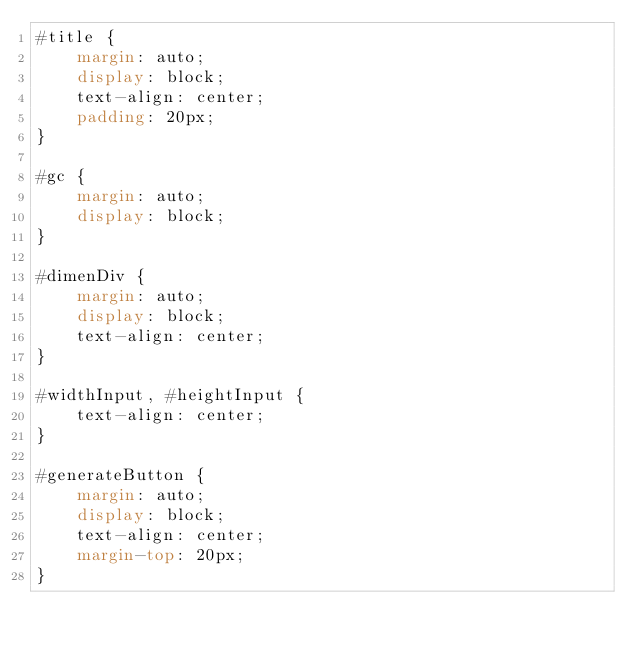<code> <loc_0><loc_0><loc_500><loc_500><_CSS_>#title {
	margin: auto;
	display: block;
	text-align: center;
	padding: 20px;
}

#gc {
	margin: auto;
	display: block;
}

#dimenDiv {
	margin: auto;
	display: block;
	text-align: center;
}

#widthInput, #heightInput {
	text-align: center;
}

#generateButton {
	margin: auto;
	display: block;
	text-align: center;
	margin-top: 20px;
}
</code> 